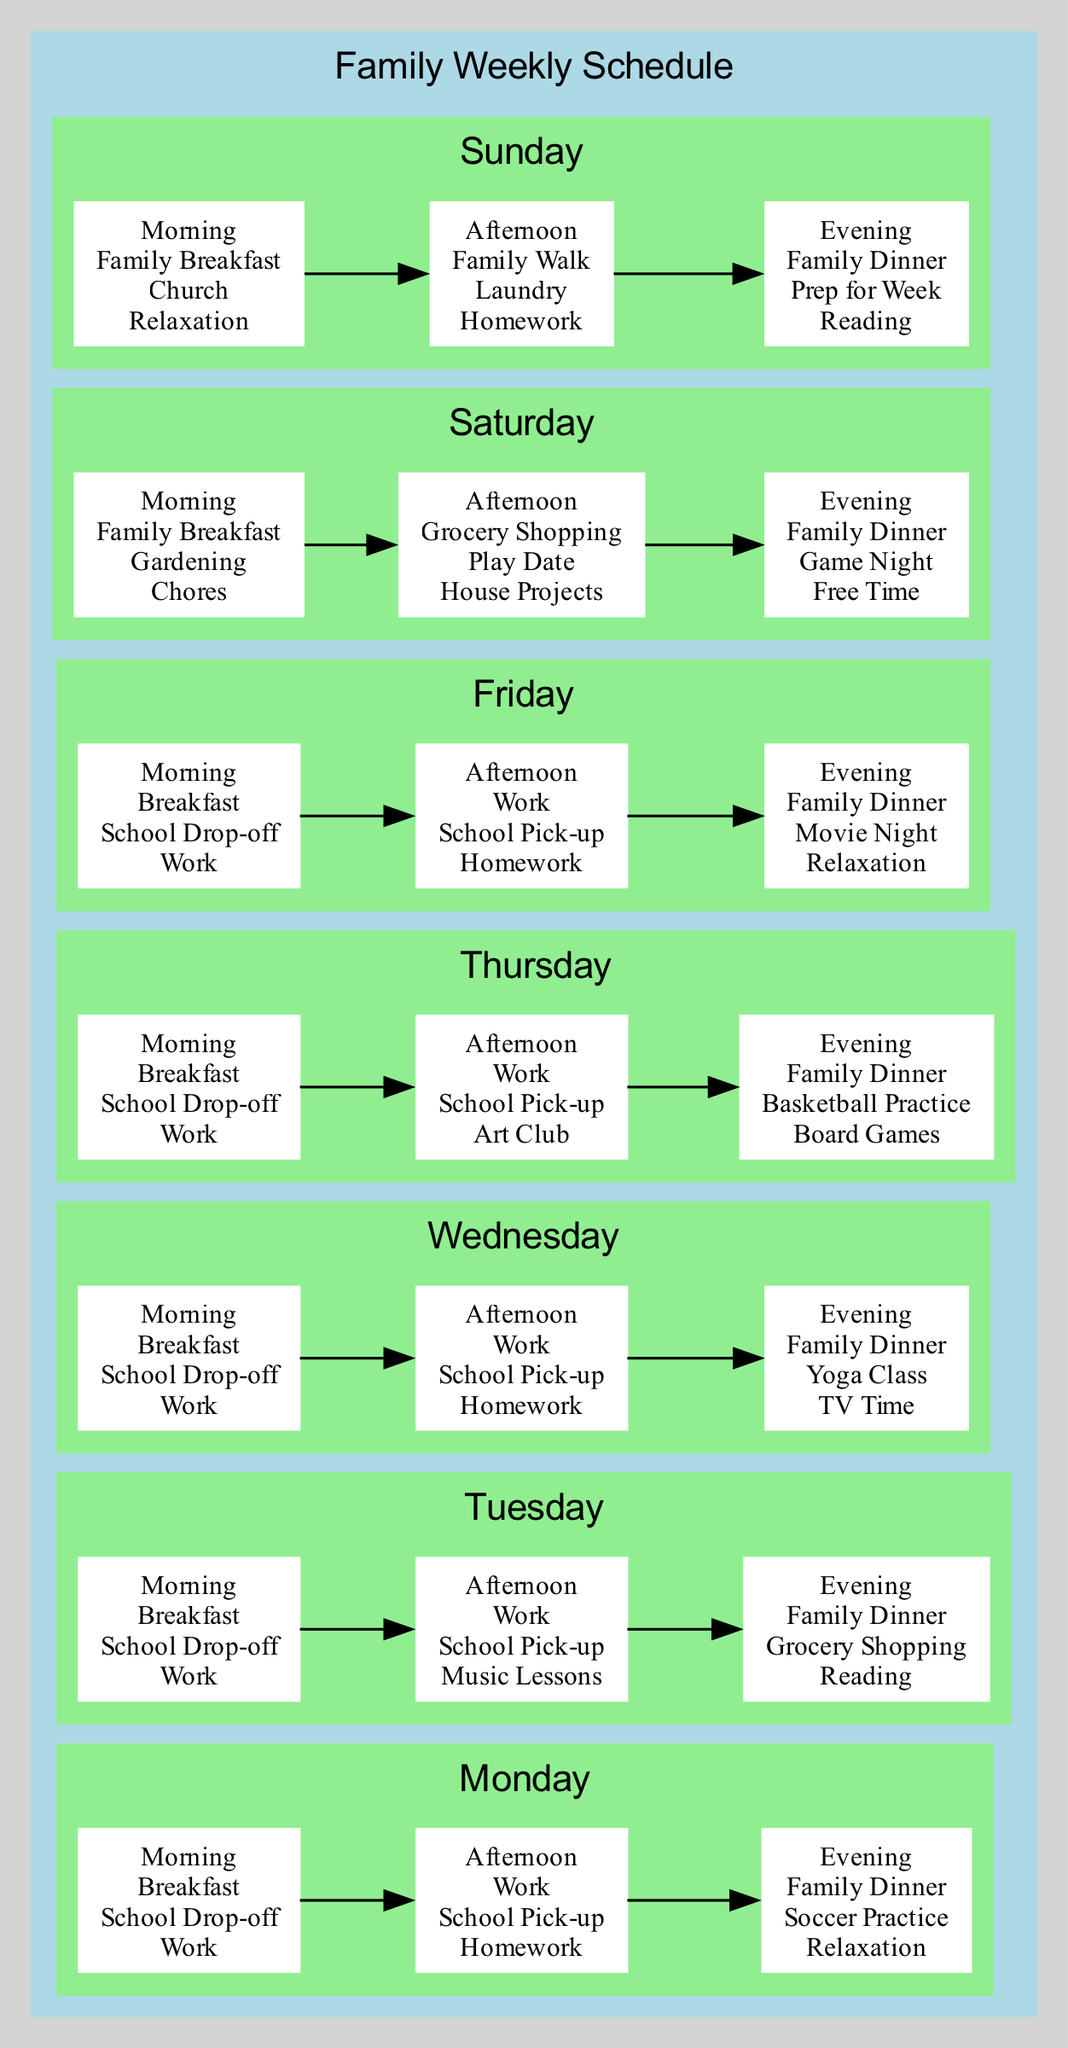What activities are planned for Saturday morning? From the diagram, the Saturday morning activities listed are Family Breakfast, Gardening, and Chores. Therefore, the answer is derived directly by looking at the corresponding node under Saturday morning.
Answer: Family Breakfast, Gardening, Chores How many chores are scheduled for Saturday? By analyzing the Saturday sections in the diagram, the only chores mentioned are Gardening and House Projects. Counting those activities gives us a total of two chores for Saturday.
Answer: 2 Which evening activity is scheduled for Wednesday? The diagram shows that the Wednesday evening activity is a Yoga Class, followed by TV Time and Family Dinner. The last node in the Wednesday evening section gives us this information directly.
Answer: Yoga Class What is the first activity on Friday? By checking the Friday section of the diagram, the first activity listed under morning is Breakfast. This comes from the ordered structure of activities for that day.
Answer: Breakfast What are the fixed expenses listed in the monthly budget? The monthly budget overview indicates that fixed expenses include Mortgage, Utilities, Insurance, and Car Payment, which can be directly referenced from the corresponding node in the budget section of the diagram.
Answer: Mortgage, Utilities, Insurance, Car Payment What type of diet is Parent2 following? In the dietary plans section of the diagram, the listed diet for Parent2 is Mediterranean Diet, which can be found clearly under the Health and Wellness Tracker's dietary planning segment.
Answer: Mediterranean Diet How many subjects did the child receive an A in? Analyzing the academic progress section reveals that the child received an A in Math, English, and Physical Education, totaling three subjects. This count can be derived from the Grades node in the academic section.
Answer: 3 What are the tasks involved in the bathroom renovation? The diagram specifies tasks for the bathroom renovation, which include Replace Tiles, Install New Fixtures, and Paint Walls. All three tasks can be directly cited from the tasks node in the Home Renovation Plan.
Answer: Replace Tiles, Install New Fixtures, Paint Walls On which day is grocery shopping scheduled? Looking through the weekly schedule, grocery shopping is scheduled for Tuesday afternoon and Saturday afternoon. This information can be cross-referenced in both day sections to validate the finding.
Answer: Tuesday, Saturday 